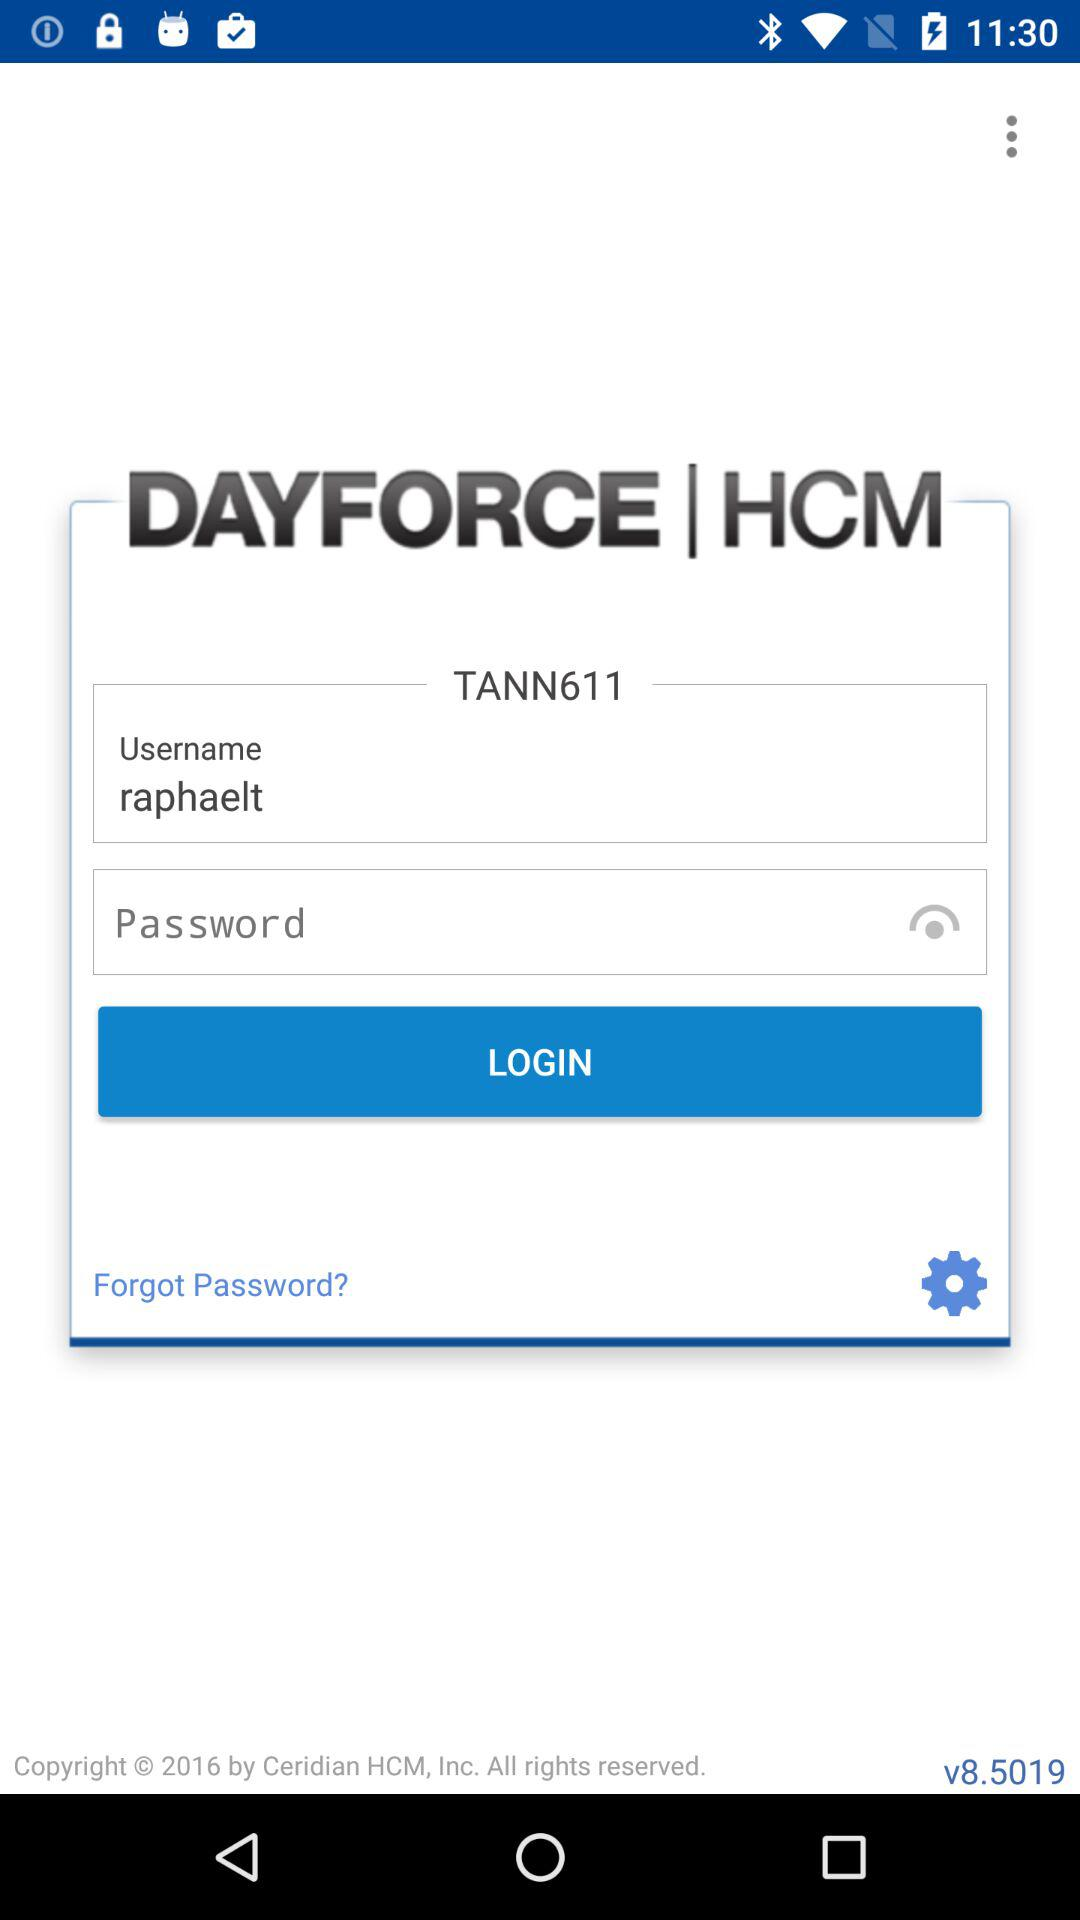What is the username? The username is "raphaelt". 